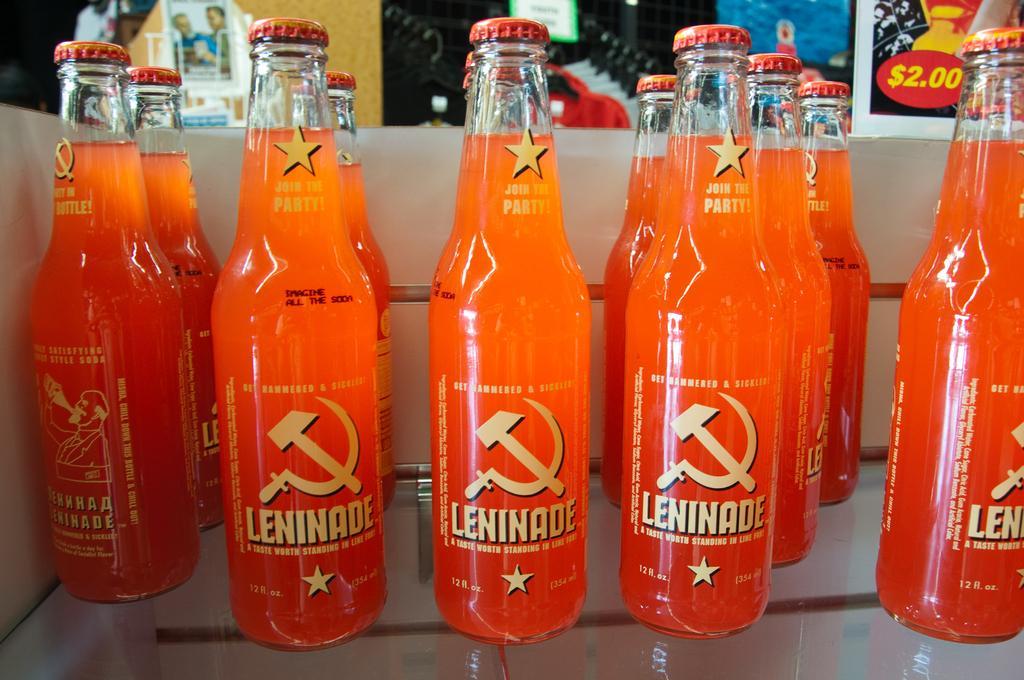Can you describe this image briefly? In this picture we can see couple of bottles and also we can see wall posters in the background. 